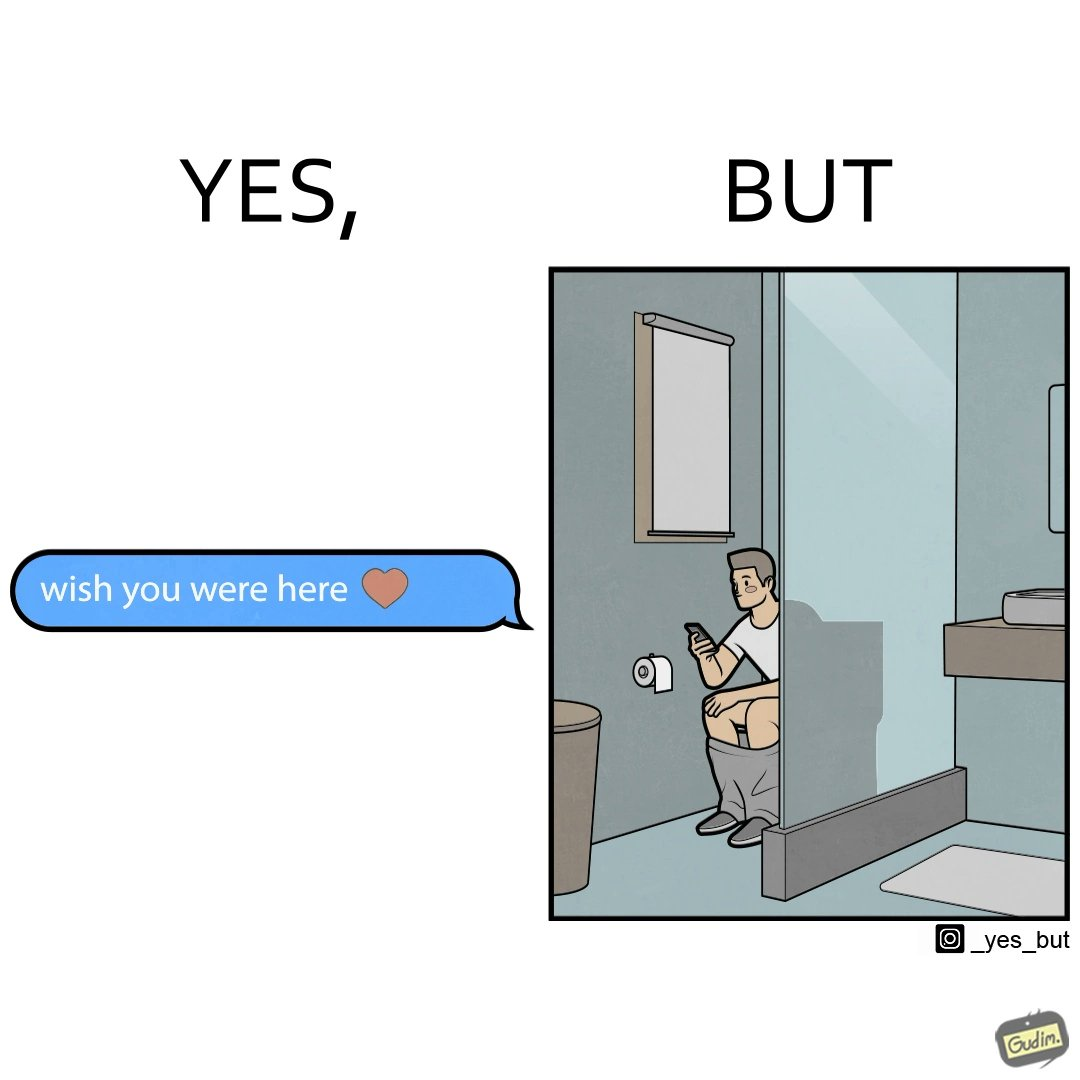What is the satirical meaning behind this image? The images are funny since it shows how even though a man writes to his partner that he wishes she was there to show that he misses her, it would be inappropriate and gross if it were to happen literally as he is sitting on his toilet 